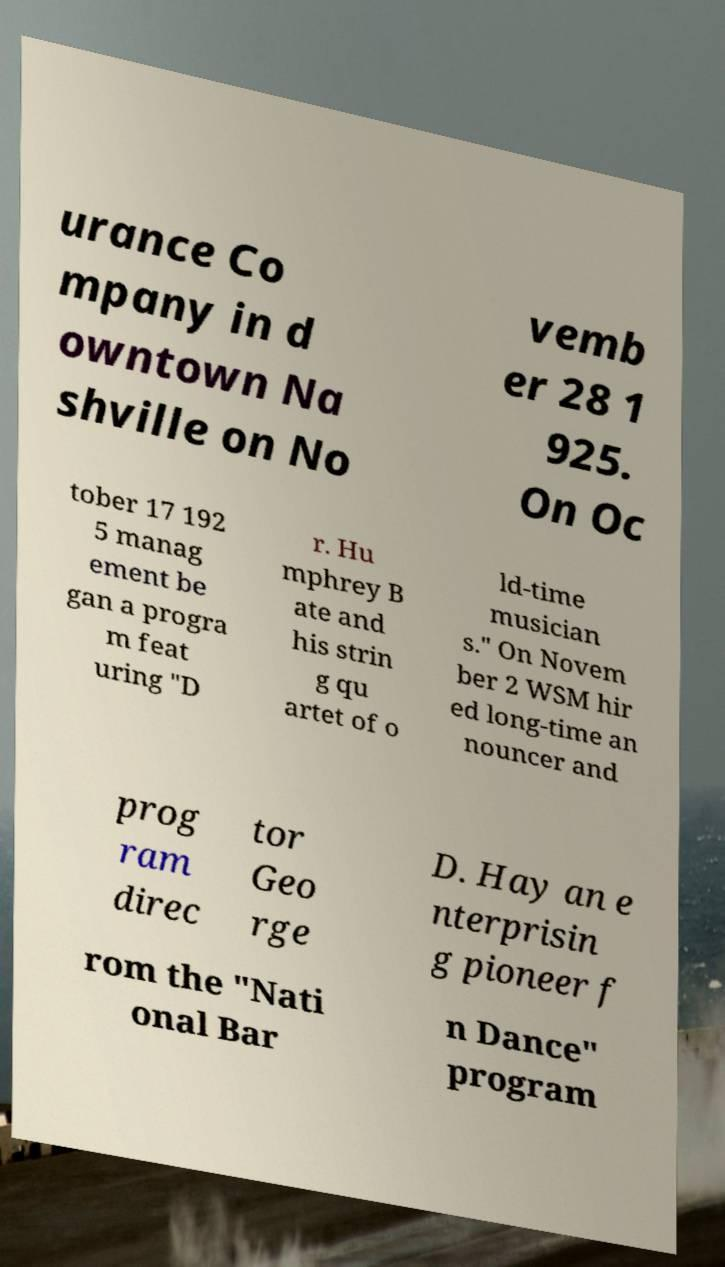Could you extract and type out the text from this image? urance Co mpany in d owntown Na shville on No vemb er 28 1 925. On Oc tober 17 192 5 manag ement be gan a progra m feat uring "D r. Hu mphrey B ate and his strin g qu artet of o ld-time musician s." On Novem ber 2 WSM hir ed long-time an nouncer and prog ram direc tor Geo rge D. Hay an e nterprisin g pioneer f rom the "Nati onal Bar n Dance" program 